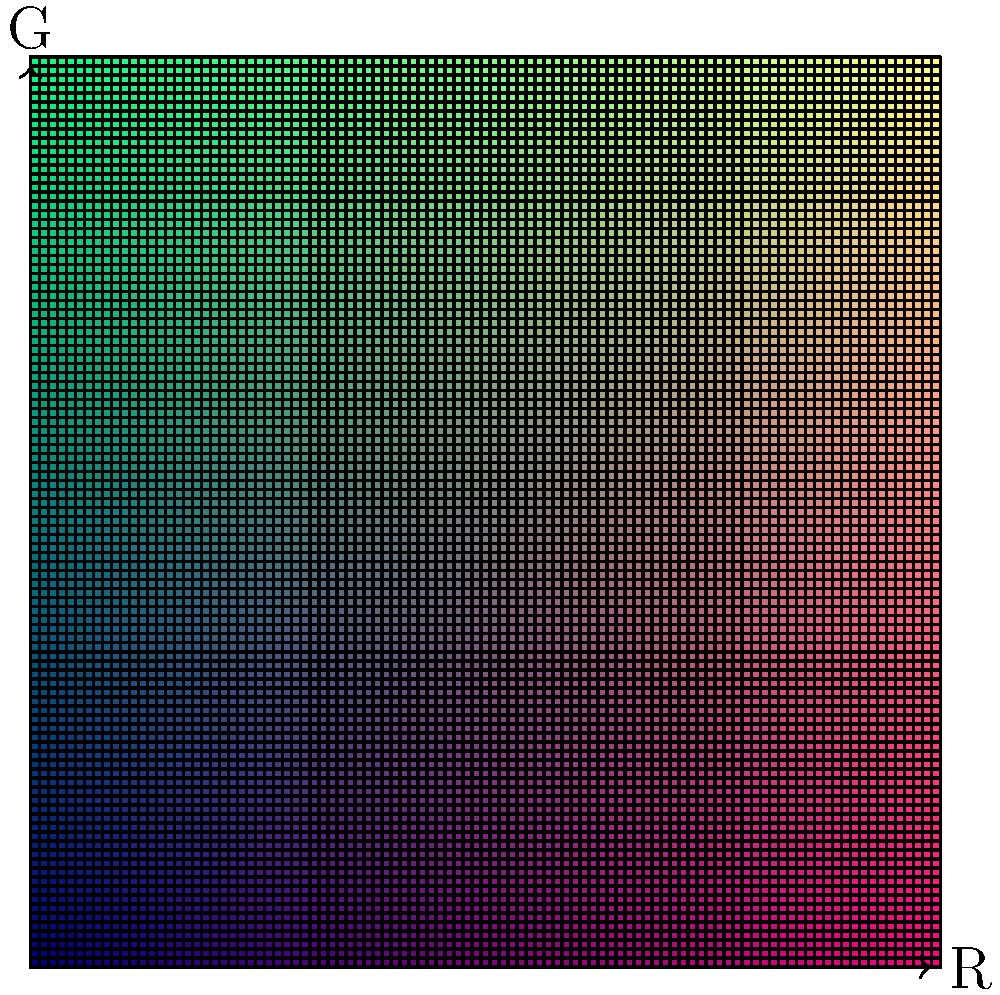In the color gradient shown above, which coordinate point $(x,y)$ would produce a pure yellow color? To determine the coordinate point that produces a pure yellow color, we need to understand how the color gradient is constructed:

1. The x-axis represents the Red (R) component, ranging from 0 to 1.
2. The y-axis represents the Green (G) component, ranging from 0 to 1.
3. The Blue (B) component is fixed at 0.5 for all points in this gradient.

To create a pure yellow color:

1. Red (R) should be at maximum intensity: $x = 1$
2. Green (G) should be at maximum intensity: $y = 1$
3. Blue (B) is already set at 0.5, which will slightly desaturate the yellow

Therefore, the coordinate point that would produce the purest yellow color in this gradient system is $(1, 1)$, corresponding to the top-right corner of the gradient.
Answer: $(1, 1)$ 